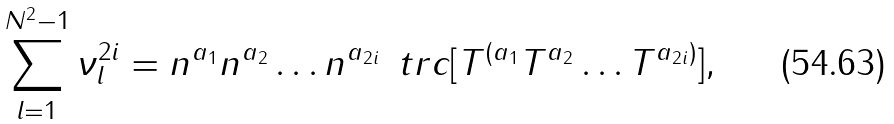<formula> <loc_0><loc_0><loc_500><loc_500>\sum _ { l = 1 } ^ { N ^ { 2 } - 1 } \nu _ { l } ^ { 2 i } = n ^ { a _ { 1 } } n ^ { a _ { 2 } } \dots n ^ { a _ { 2 i } } \, \ t r c [ T ^ { ( a _ { 1 } } T ^ { a _ { 2 } } \dots T ^ { a _ { 2 i } ) } ] ,</formula> 